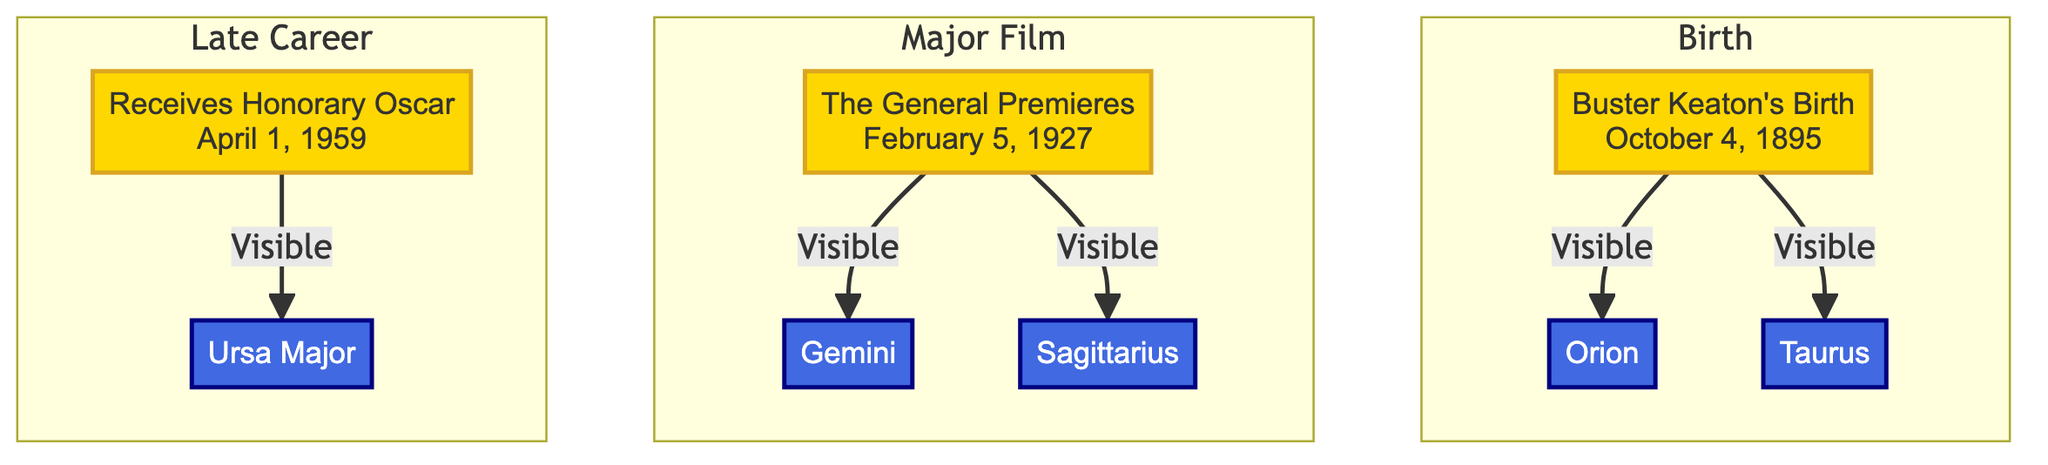What date is listed for Buster Keaton's birth? The diagram specifies the date for Buster Keaton's birth as October 4, 1895. Therefore, this is the direct answer from the node containing his birth information.
Answer: October 4, 1895 Which constellations are visible during Buster Keaton's birth? The diagram shows two constellations visible at that time: Orion and Taurus, connected to his birth node.
Answer: Orion, Taurus What event is associated with February 5, 1927? This event node directly mentions that it is the premiere of "The General," which is clearly indicated in the diagram.
Answer: The General Premieres How many constellations are visible during the major film milestone? The major film milestone connects to two constellations: Gemini and Sagittarius, so counting them gives the total.
Answer: 2 Which constellation is visible during the late career? The late career node connects to the constellation Ursa Major, which shows its visibility at that stage.
Answer: Ursa Major What is the relationship between Buster Keaton's birth and the constellations? The arrows from the birth node indicate a direct visibility connection to the constellations Orion and Taurus, establishing this relationship in the diagram.
Answer: Visible to Orion, Taurus What significant award did Buster Keaton receive on April 1, 1959? The diagram indicates that Buster Keaton received an Honorary Oscar on this date, which is clearly labeled in the event node.
Answer: Honorary Oscar Which event is connected to the constellation Gemini? The diagram visually links the event of "The General" premiere to the constellation Gemini, demonstrating their connection through the arrows.
Answer: The General Premieres What are the visible constellations associated with Buster Keaton's major film milestone? The diagram lists two constellations clearly connected to "The General" premiere, which are Gemini and Sagittarius.
Answer: Gemini, Sagittarius 